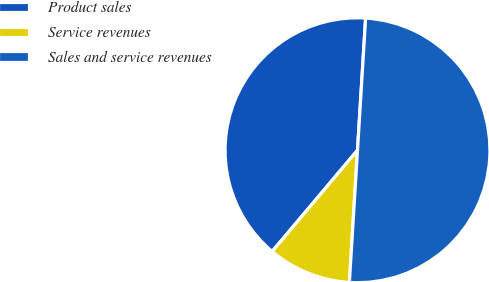<chart> <loc_0><loc_0><loc_500><loc_500><pie_chart><fcel>Product sales<fcel>Service revenues<fcel>Sales and service revenues<nl><fcel>39.83%<fcel>10.17%<fcel>50.0%<nl></chart> 